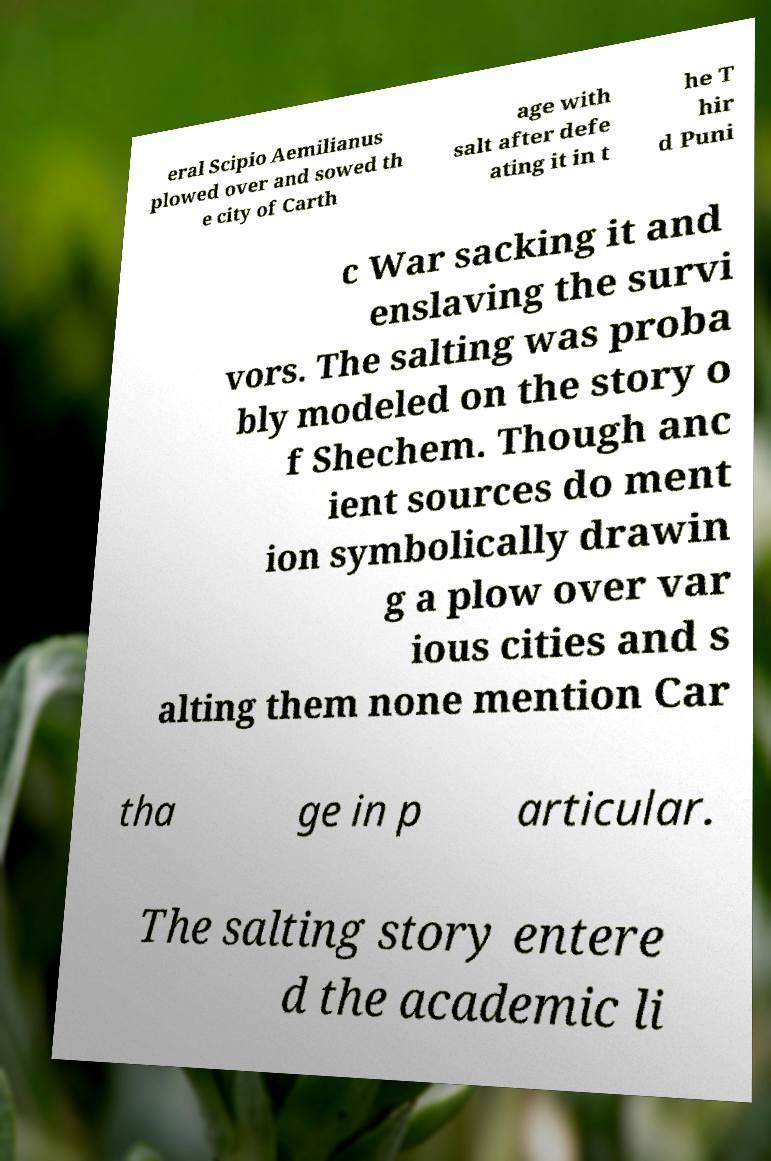What messages or text are displayed in this image? I need them in a readable, typed format. eral Scipio Aemilianus plowed over and sowed th e city of Carth age with salt after defe ating it in t he T hir d Puni c War sacking it and enslaving the survi vors. The salting was proba bly modeled on the story o f Shechem. Though anc ient sources do ment ion symbolically drawin g a plow over var ious cities and s alting them none mention Car tha ge in p articular. The salting story entere d the academic li 